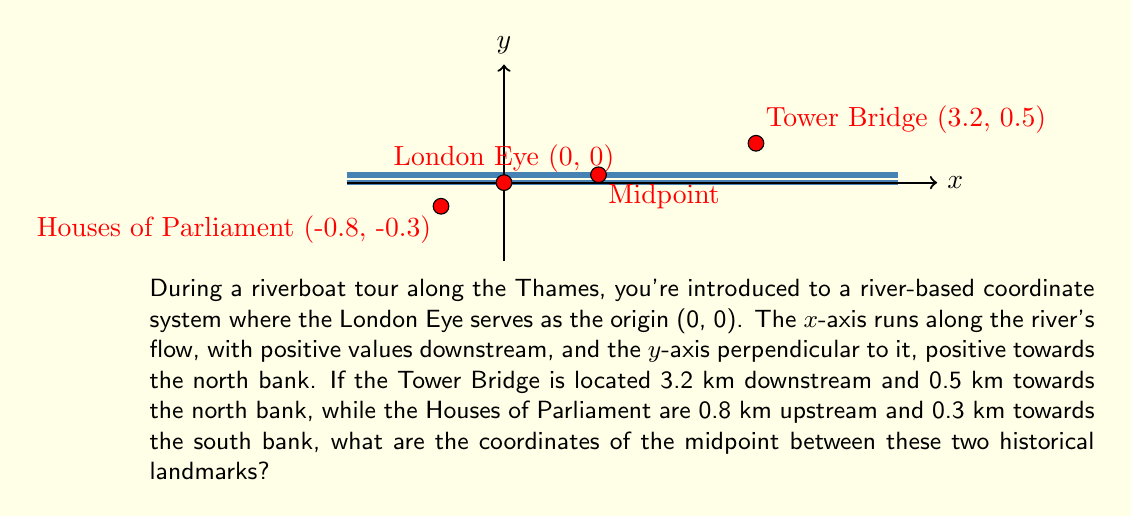Teach me how to tackle this problem. To find the midpoint between two points, we need to average their x-coordinates and y-coordinates separately. Let's approach this step-by-step:

1) First, let's identify the coordinates of each landmark:
   - Tower Bridge: (3.2, 0.5)
   - Houses of Parliament: (-0.8, -0.3)

2) The formula for the midpoint $(x_m, y_m)$ between two points $(x_1, y_1)$ and $(x_2, y_2)$ is:

   $$(x_m, y_m) = (\frac{x_1 + x_2}{2}, \frac{y_1 + y_2}{2})$$

3) Let's calculate the x-coordinate of the midpoint:
   $$x_m = \frac{3.2 + (-0.8)}{2} = \frac{2.4}{2} = 1.2$$

4) Now, let's calculate the y-coordinate of the midpoint:
   $$y_m = \frac{0.5 + (-0.3)}{2} = \frac{0.2}{2} = 0.1$$

5) Therefore, the coordinates of the midpoint are (1.2, 0.1).

This point is located 1.2 km downstream from the London Eye and 0.1 km towards the north bank.
Answer: (1.2, 0.1) 